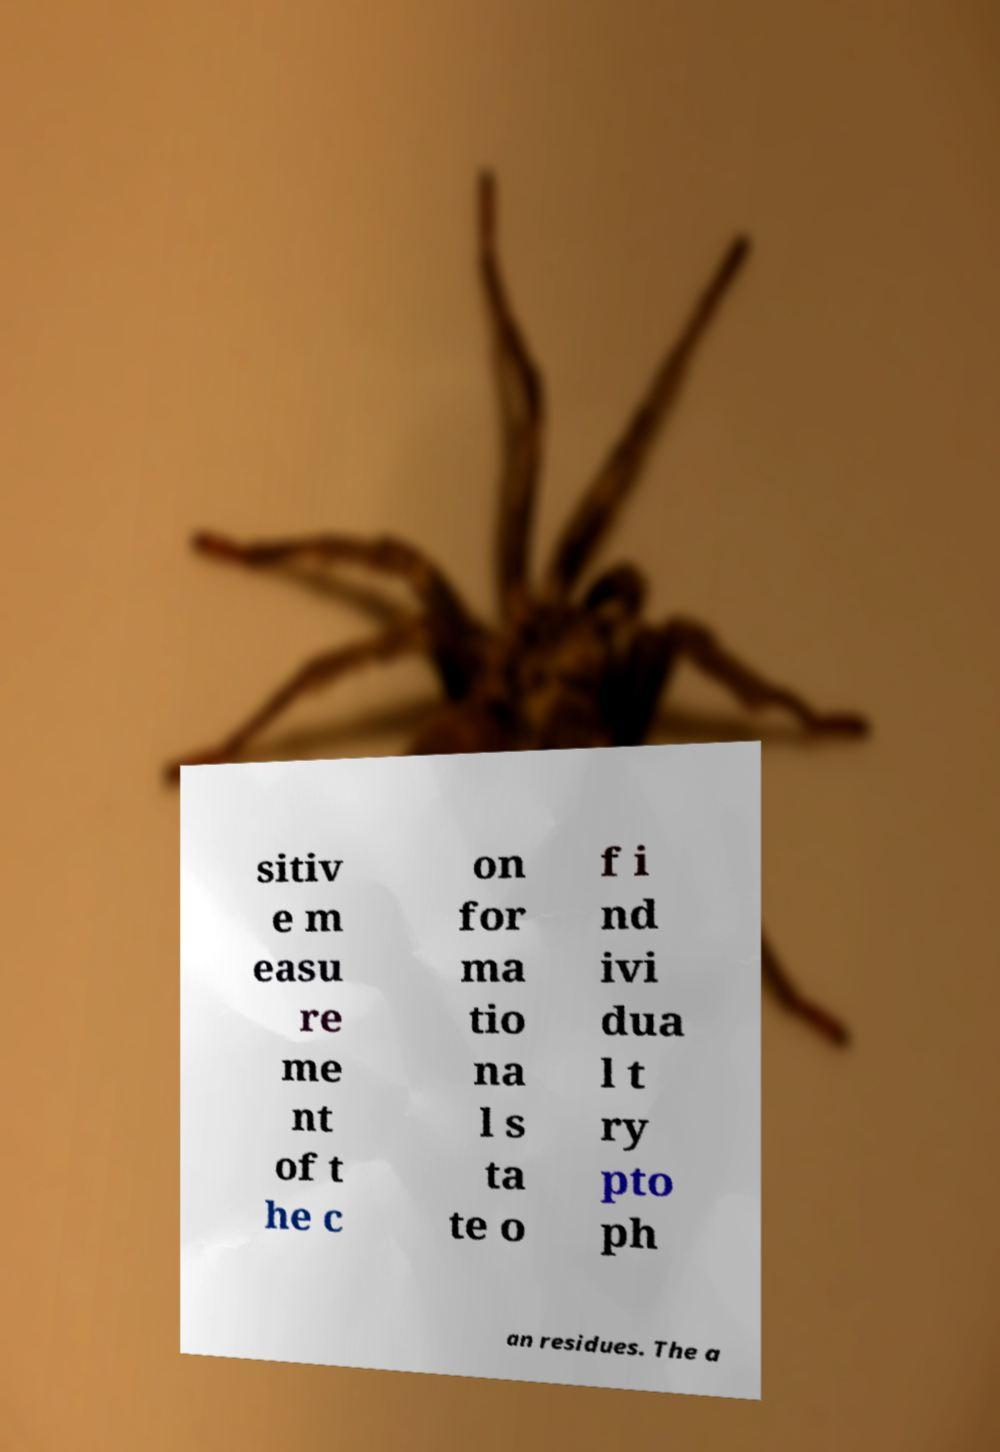There's text embedded in this image that I need extracted. Can you transcribe it verbatim? sitiv e m easu re me nt of t he c on for ma tio na l s ta te o f i nd ivi dua l t ry pto ph an residues. The a 